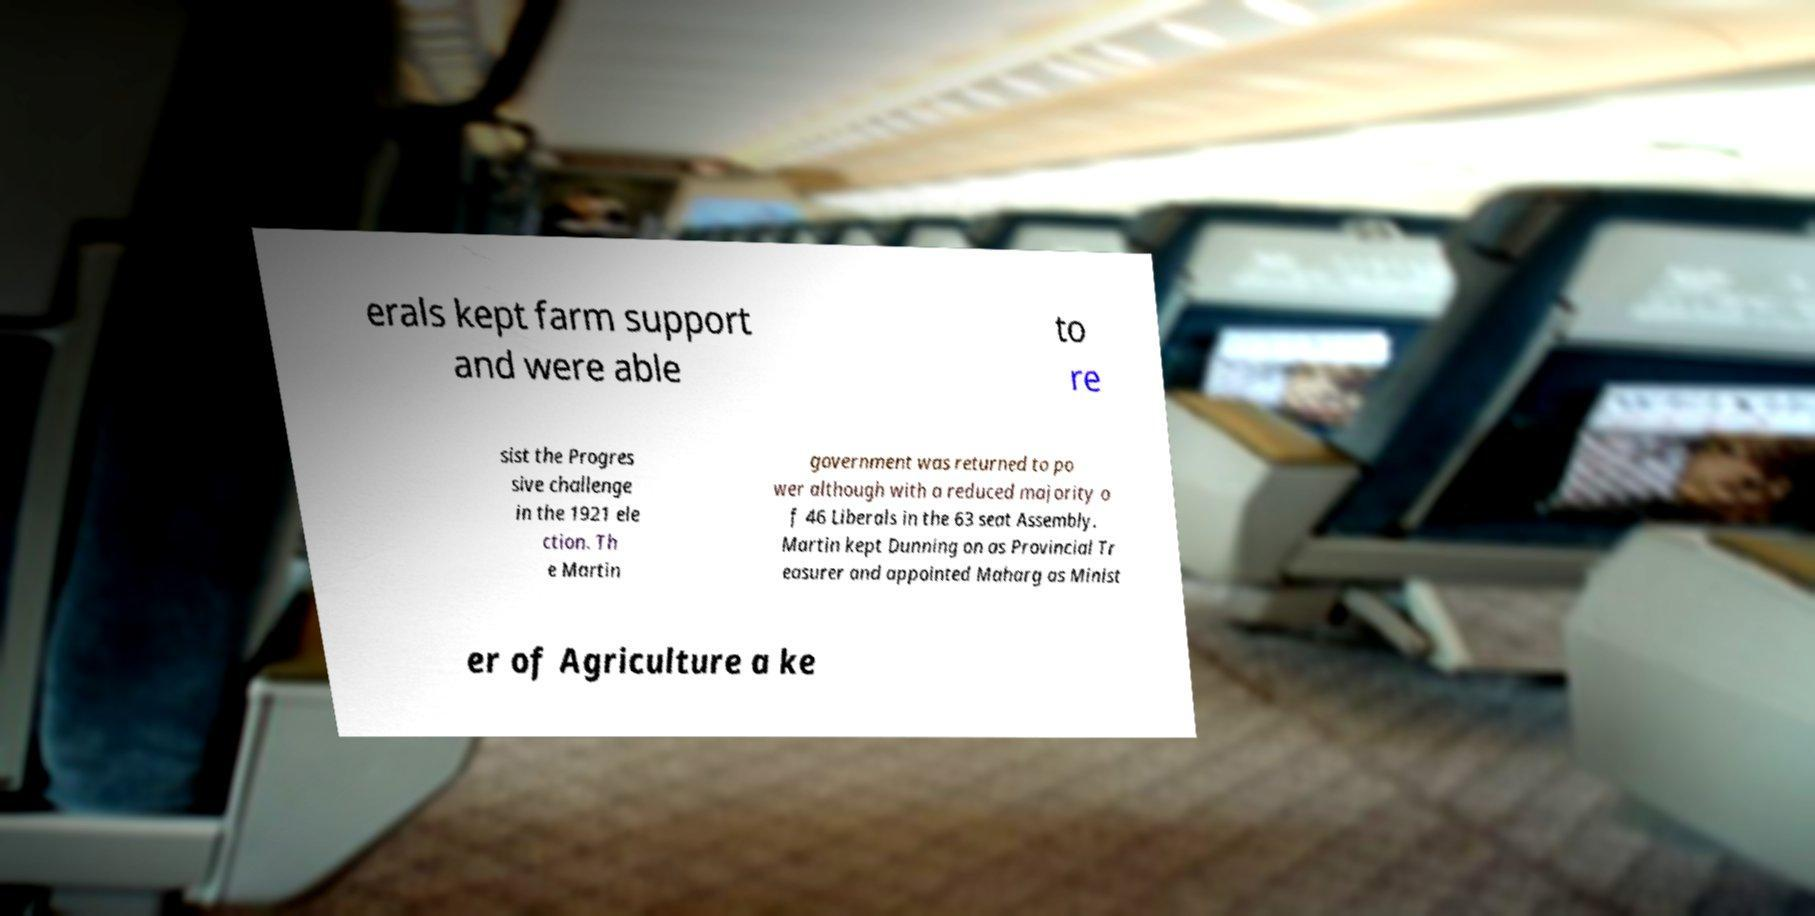Could you assist in decoding the text presented in this image and type it out clearly? erals kept farm support and were able to re sist the Progres sive challenge in the 1921 ele ction. Th e Martin government was returned to po wer although with a reduced majority o f 46 Liberals in the 63 seat Assembly. Martin kept Dunning on as Provincial Tr easurer and appointed Maharg as Minist er of Agriculture a ke 